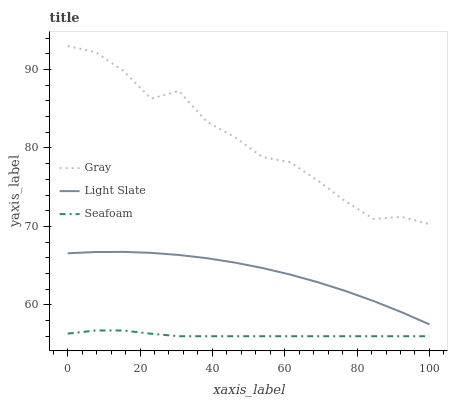Does Seafoam have the minimum area under the curve?
Answer yes or no. Yes. Does Gray have the maximum area under the curve?
Answer yes or no. Yes. Does Gray have the minimum area under the curve?
Answer yes or no. No. Does Seafoam have the maximum area under the curve?
Answer yes or no. No. Is Seafoam the smoothest?
Answer yes or no. Yes. Is Gray the roughest?
Answer yes or no. Yes. Is Gray the smoothest?
Answer yes or no. No. Is Seafoam the roughest?
Answer yes or no. No. Does Seafoam have the lowest value?
Answer yes or no. Yes. Does Gray have the lowest value?
Answer yes or no. No. Does Gray have the highest value?
Answer yes or no. Yes. Does Seafoam have the highest value?
Answer yes or no. No. Is Seafoam less than Light Slate?
Answer yes or no. Yes. Is Gray greater than Light Slate?
Answer yes or no. Yes. Does Seafoam intersect Light Slate?
Answer yes or no. No. 